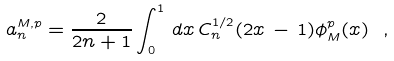<formula> <loc_0><loc_0><loc_500><loc_500>a _ { n } ^ { M , p } = \frac { 2 } { 2 n + 1 } \int _ { 0 } ^ { 1 } \, d x \, C _ { n } ^ { 1 / 2 } ( 2 x \, - \, 1 ) \phi _ { M } ^ { p } ( x ) \ ,</formula> 